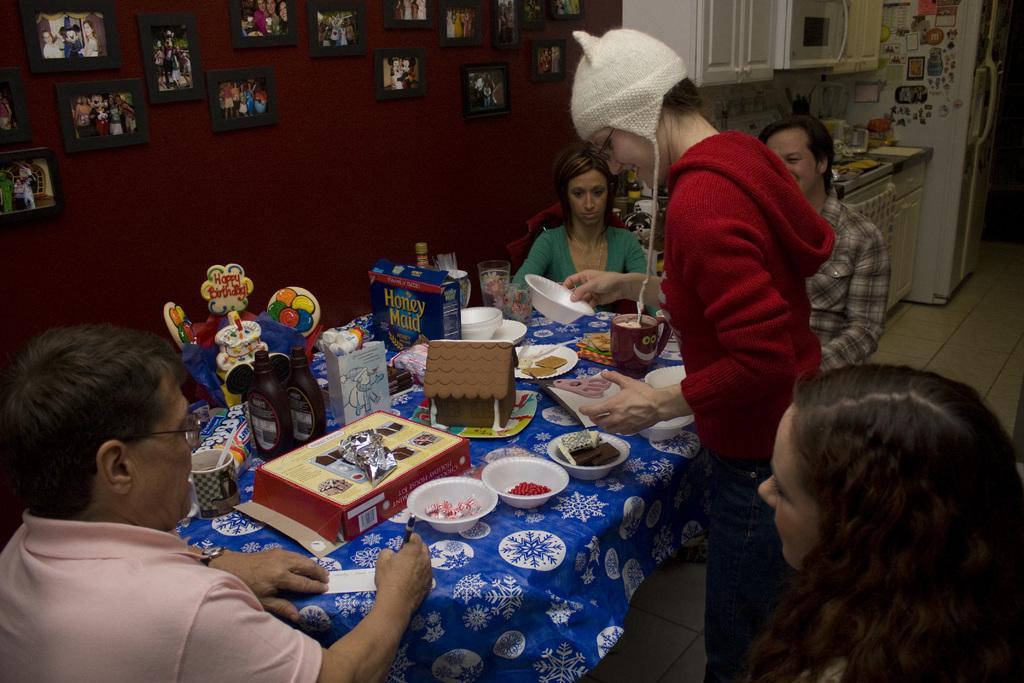Could you give a brief overview of what you see in this image? In this picture we can see three people sitting in front of a table, there are two persons here, we can see some bowls, a plate, boxes, bottles, a mug present on the table, on the left side there is a wall, we can see photo frames on the wall, in the background there is a counter top, we can see a microwave oven and a fridge here. 